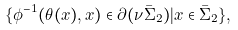Convert formula to latex. <formula><loc_0><loc_0><loc_500><loc_500>\{ \phi ^ { - 1 } ( \theta ( x ) , x ) \in \partial ( \nu \bar { \Sigma } _ { 2 } ) | x \in \bar { \Sigma } _ { 2 } \} ,</formula> 